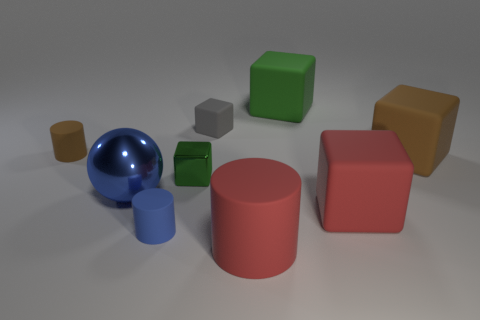Subtract all red matte cylinders. How many cylinders are left? 2 Subtract all brown blocks. How many blocks are left? 4 Subtract all spheres. How many objects are left? 8 Add 9 gray rubber cubes. How many gray rubber cubes are left? 10 Add 5 big blue balls. How many big blue balls exist? 6 Subtract 0 green cylinders. How many objects are left? 9 Subtract 1 spheres. How many spheres are left? 0 Subtract all red spheres. Subtract all yellow cubes. How many spheres are left? 1 Subtract all purple cylinders. How many yellow spheres are left? 0 Subtract all purple spheres. Subtract all blue rubber things. How many objects are left? 8 